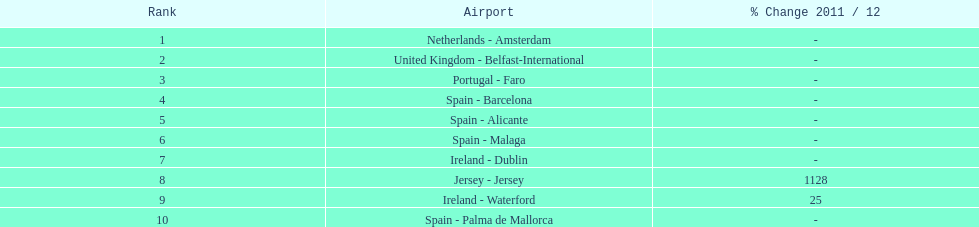What is the number of passengers traveling to or arriving from spain? 217,548. 